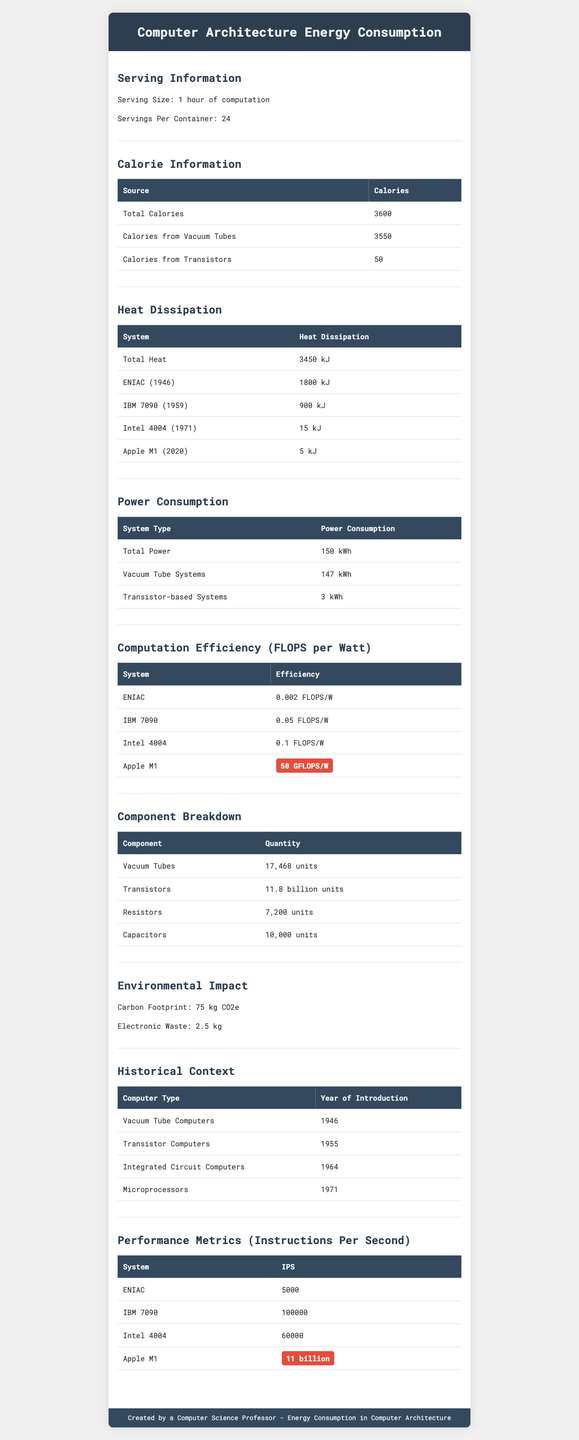What is the serving size mentioned in the document? The serving size is listed at the beginning of the Serving Information section.
Answer: 1 hour of computation How many total calories are consumed per serving? The total calories information is given in the Calorie Information section under "Total Calories."
Answer: 3600 How much heat does the Apple M1 (2020) system dissipate? This information is provided in the Heat Dissipation section under the Apple M1 (2020).
Answer: 5 kJ How many vacuum tubes are required in the ENIAC system? The Component Breakdown section notes that 17,468 vacuum tubes are used.
Answer: 17,468 What is the power consumption of transistor-based systems? This is stated in the Power Consumption section under "Transistor-based Systems."
Answer: 3 kWh What is the FLOPS per Watt efficiency of the Intel 4004? This value is listed in the Computation Efficiency section under Intel 4004.
Answer: 0.1 FLOPS/W What year was the IBM 7090 introduced? A. 1946 B. 1955 C. 1959 The Historical Context section lists the year of introduction for IBM 7090 as 1959.
Answer: C. 1959 Which system has the highest instructions per second (IPS)? I. ENIAC II. IBM 7090 III. Apple M1 The Performance Metrics section shows Apple M1 with 11 billion IPS, the highest among listed systems.
Answer: III. Apple M1 Do vacuum tube systems consume more power than transistor-based systems? The Power Consumption section shows 147 kWh for vacuum tube systems and 3 kWh for transistor-based systems.
Answer: Yes Summarize the document. Each section in the document offers detailed statistics and comparisons, showing the technological progression from early vacuum tube computers to modern systems like Apple M1.
Answer: The document provides an overview of energy consumption and efficiency metrics for historical and modern computer architectures, including key information on caloric expenditure, heat dissipation, power consumption, computation efficiency, component breakdown, and environmental impact. How often do transistor failures occur? The document only states "1 per year" for transistor failures but does not specify the exact conditions or system details associated with this rate.
Answer: Cannot be determined 